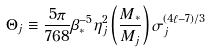Convert formula to latex. <formula><loc_0><loc_0><loc_500><loc_500>\Theta _ { j } \equiv \frac { 5 \pi } { 7 6 8 } \beta _ { \ast } ^ { - 5 } \eta _ { j } ^ { 2 } \left ( \frac { M _ { \ast } } { M _ { j } } \right ) \sigma _ { j } ^ { ( 4 \ell - 7 ) / 3 }</formula> 